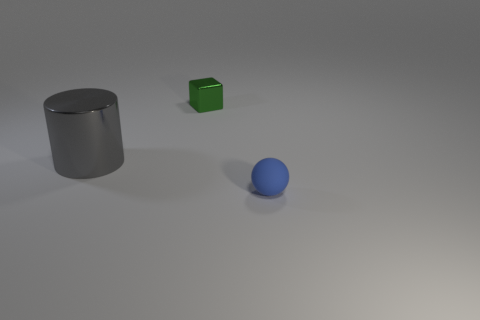Is there anything else that has the same size as the shiny cylinder?
Keep it short and to the point. No. Are there any other things that have the same shape as the green metallic object?
Offer a terse response. No. There is a small object behind the gray metallic cylinder; what shape is it?
Keep it short and to the point. Cube. How big is the shiny object that is in front of the tiny thing that is behind the small thing in front of the metallic cylinder?
Keep it short and to the point. Large. What number of rubber things are on the right side of the small thing right of the small green metallic block?
Your answer should be compact. 0. How big is the object that is in front of the small green metal block and to the left of the small sphere?
Your answer should be very brief. Large. How many shiny objects are either blue spheres or big blue blocks?
Provide a short and direct response. 0. What is the material of the tiny blue object?
Make the answer very short. Rubber. There is a tiny object in front of the shiny object to the left of the small thing behind the sphere; what is its material?
Your response must be concise. Rubber. What shape is the other object that is the same size as the green object?
Your answer should be compact. Sphere. 